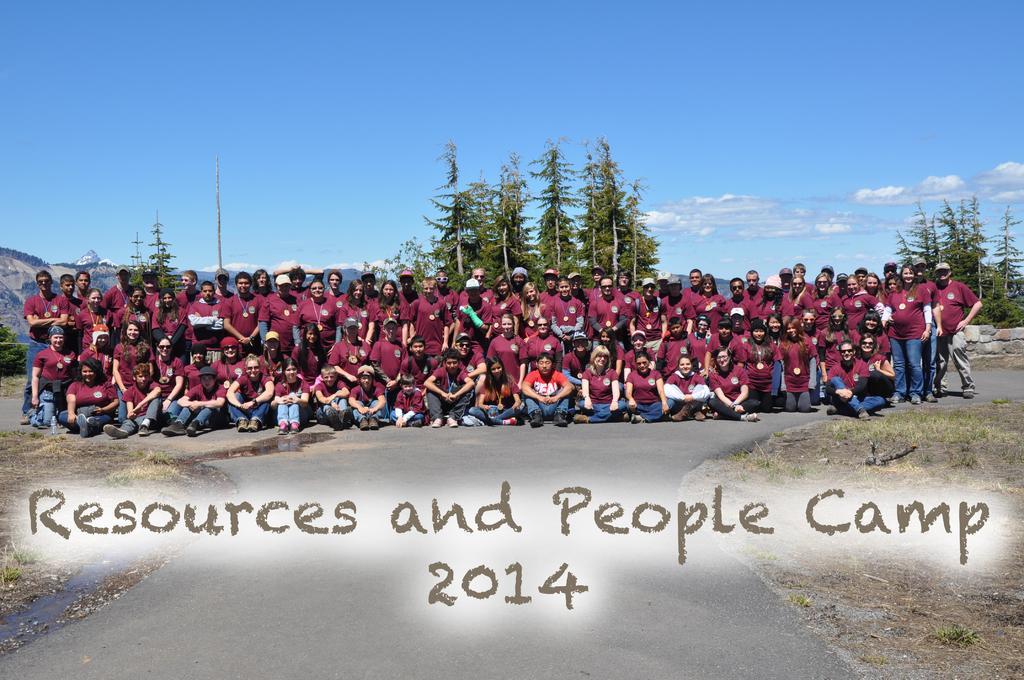Please provide a concise description of this image. In the foreground, I can see a text, grass and a group of people on the road. In the background, I can see trees, fence, mountains and the sky. This image taken, maybe during a day. 